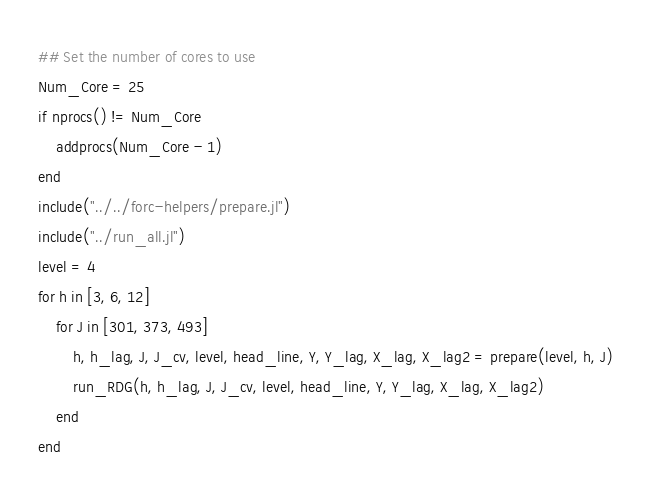Convert code to text. <code><loc_0><loc_0><loc_500><loc_500><_Julia_>## Set the number of cores to use
Num_Core = 25
if nprocs() != Num_Core
    addprocs(Num_Core - 1)
end
include("../../forc-helpers/prepare.jl")
include("../run_all.jl")
level = 4
for h in [3, 6, 12]
    for J in [301, 373, 493]
        h, h_lag, J, J_cv, level, head_line, Y, Y_lag, X_lag, X_lag2 = prepare(level, h, J)
        run_RDG(h, h_lag, J, J_cv, level, head_line, Y, Y_lag, X_lag, X_lag2)
    end
end
</code> 